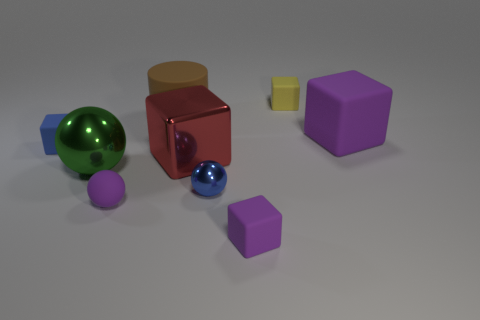Subtract all yellow cubes. How many cubes are left? 4 Subtract all large matte blocks. How many blocks are left? 4 Subtract all brown blocks. Subtract all yellow cylinders. How many blocks are left? 5 Add 1 big brown matte cylinders. How many objects exist? 10 Subtract all balls. How many objects are left? 6 Subtract 0 yellow cylinders. How many objects are left? 9 Subtract all small green rubber cylinders. Subtract all matte blocks. How many objects are left? 5 Add 2 big metal balls. How many big metal balls are left? 3 Add 8 red metallic blocks. How many red metallic blocks exist? 9 